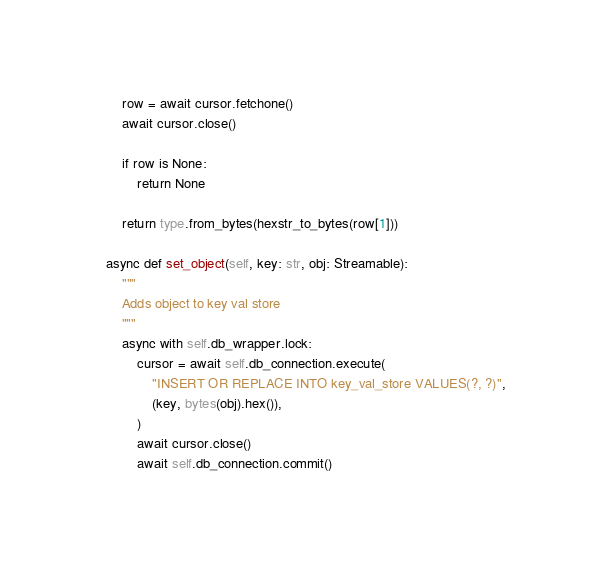Convert code to text. <code><loc_0><loc_0><loc_500><loc_500><_Python_>        row = await cursor.fetchone()
        await cursor.close()

        if row is None:
            return None

        return type.from_bytes(hexstr_to_bytes(row[1]))

    async def set_object(self, key: str, obj: Streamable):
        """
        Adds object to key val store
        """
        async with self.db_wrapper.lock:
            cursor = await self.db_connection.execute(
                "INSERT OR REPLACE INTO key_val_store VALUES(?, ?)",
                (key, bytes(obj).hex()),
            )
            await cursor.close()
            await self.db_connection.commit()
</code> 